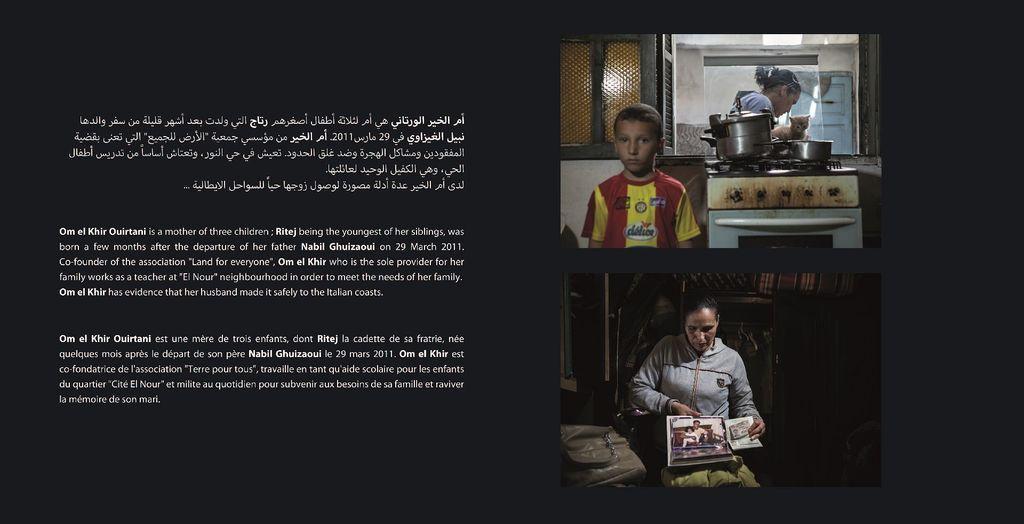How would you summarize this image in a sentence or two? In this image I can see two pictures. A picture of a woman sitting on a chair and holding few objects in her hand and I can see a bag beside her and few books in the bookshelf behind her. Another picture of a boy wearing red and yellow colored t shirt, a gas stove with few bowls on it, a woman and a cat. I can see the window. I can see the black colored background on which I can see few words written in different languages. 